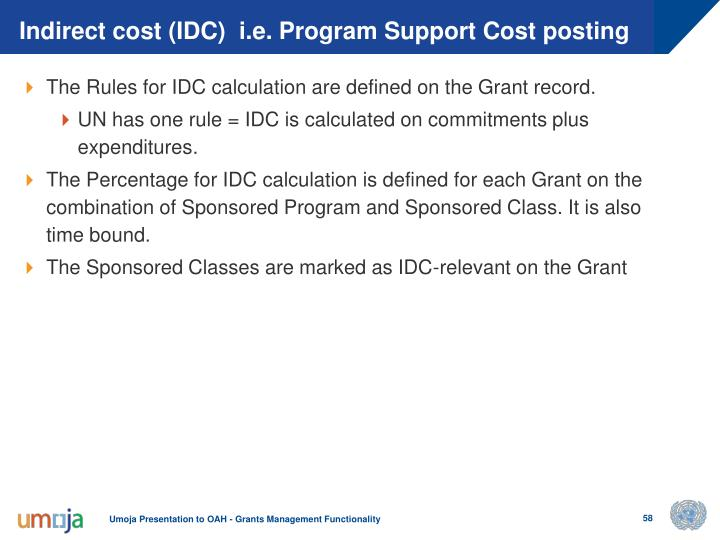What is the significance of marking Sponsored Classes as IDC-relevant on the Grant, and how could this impact grant management? Marking Sponsored Classes as IDC-relevant on the Grant is a critical step in the financial management of grants. This designation ensures that expenses related to these classes are factored into the calculation of indirect costs, or IDC. Effective management of IDC is essential because it ensures that funds are allocated correctly between direct and indirect expenses, allowing for a transparent audit trail and compliance with financial regulations. Calculating IDC incorrectly can lead to budget overruns or underutilization of funds, impacting the overall efficacy of managed grants. By maintaining accuracy in this marking, institutions can uphold integrity and accountability in financial reporting. 